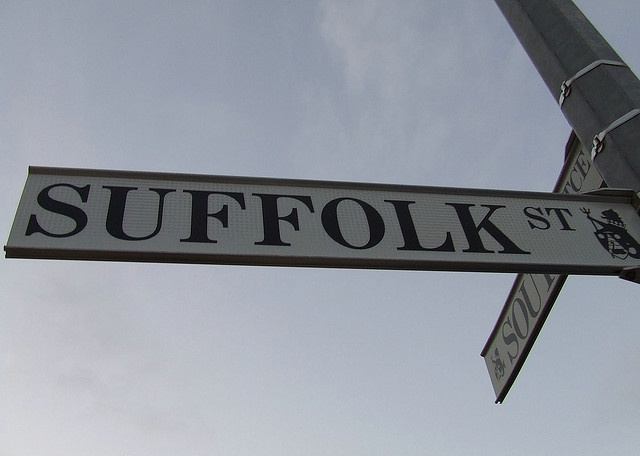Describe the objects in this image and their specific colors. I can see various objects in this image with different colors. 